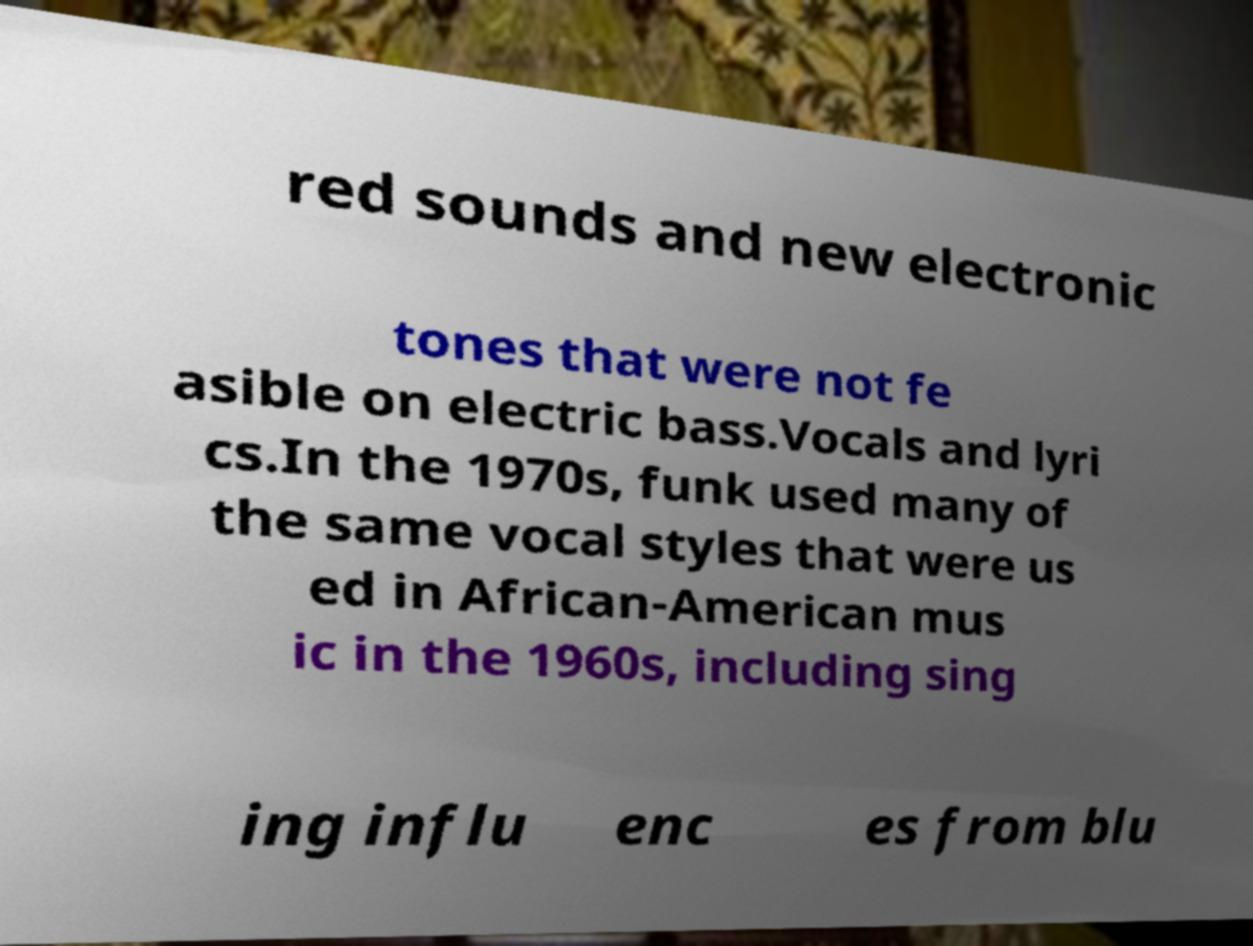Could you extract and type out the text from this image? red sounds and new electronic tones that were not fe asible on electric bass.Vocals and lyri cs.In the 1970s, funk used many of the same vocal styles that were us ed in African-American mus ic in the 1960s, including sing ing influ enc es from blu 